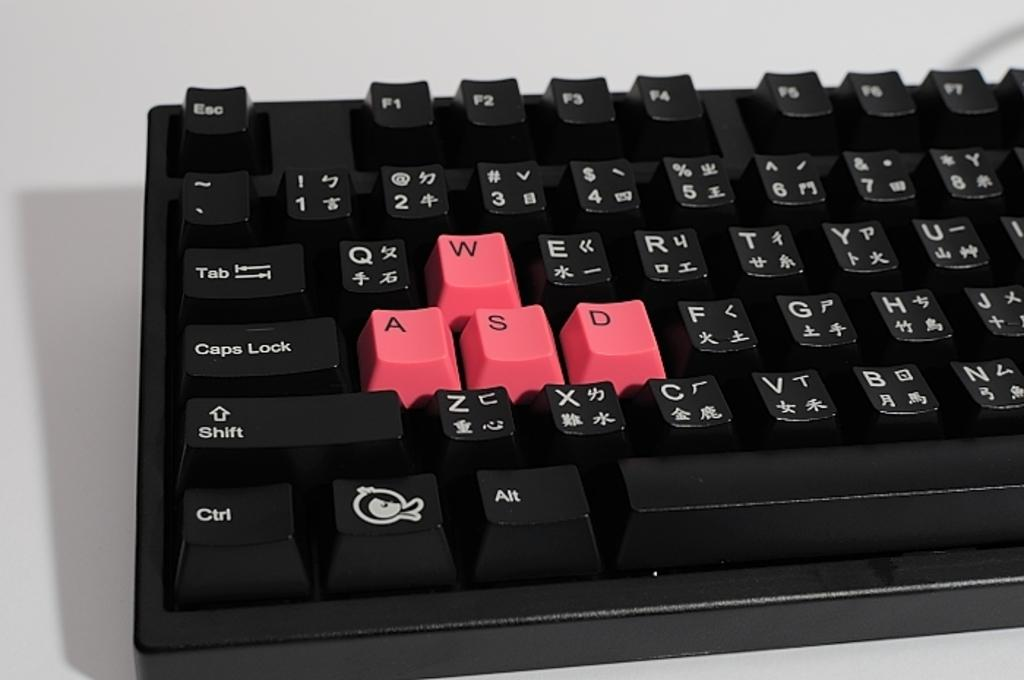<image>
Relay a brief, clear account of the picture shown. A keyboard sitting on a white table with the WASD keys marked in red. 